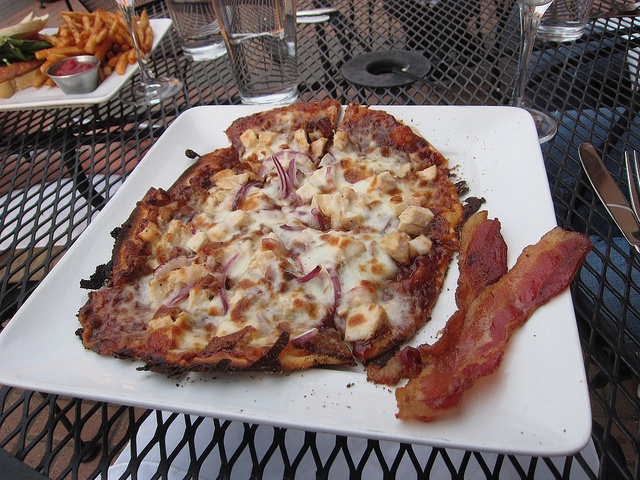Describe the objects in this image and their specific colors. I can see dining table in black, lightgray, gray, maroon, and brown tones, pizza in gray, maroon, brown, tan, and darkgray tones, cup in gray, black, and darkgray tones, sandwich in gray, black, brown, and maroon tones, and cup in gray, black, lightgray, and darkgray tones in this image. 